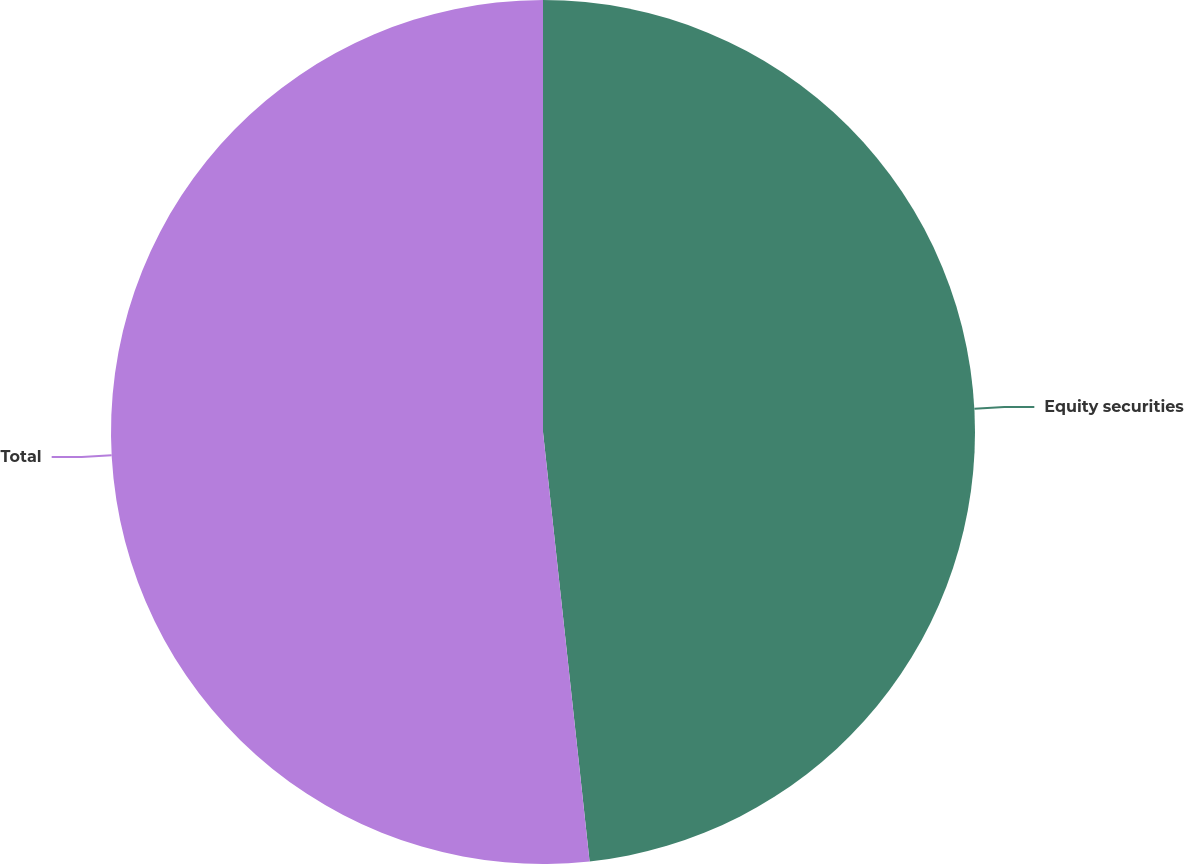Convert chart. <chart><loc_0><loc_0><loc_500><loc_500><pie_chart><fcel>Equity securities<fcel>Total<nl><fcel>48.28%<fcel>51.72%<nl></chart> 